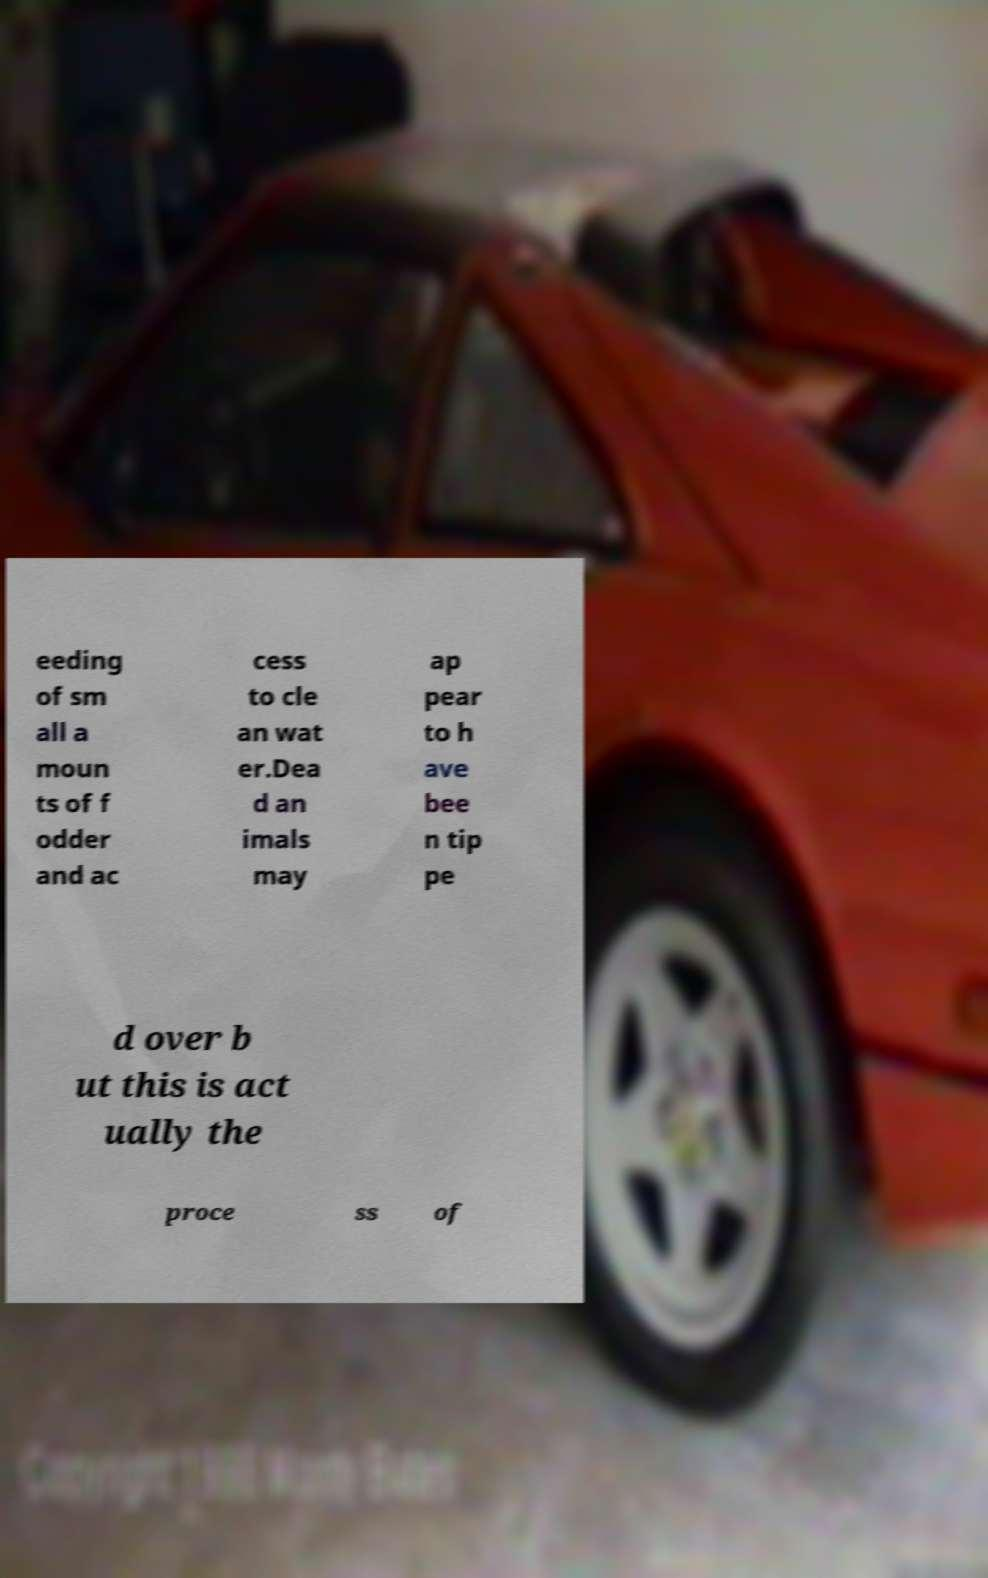There's text embedded in this image that I need extracted. Can you transcribe it verbatim? eeding of sm all a moun ts of f odder and ac cess to cle an wat er.Dea d an imals may ap pear to h ave bee n tip pe d over b ut this is act ually the proce ss of 